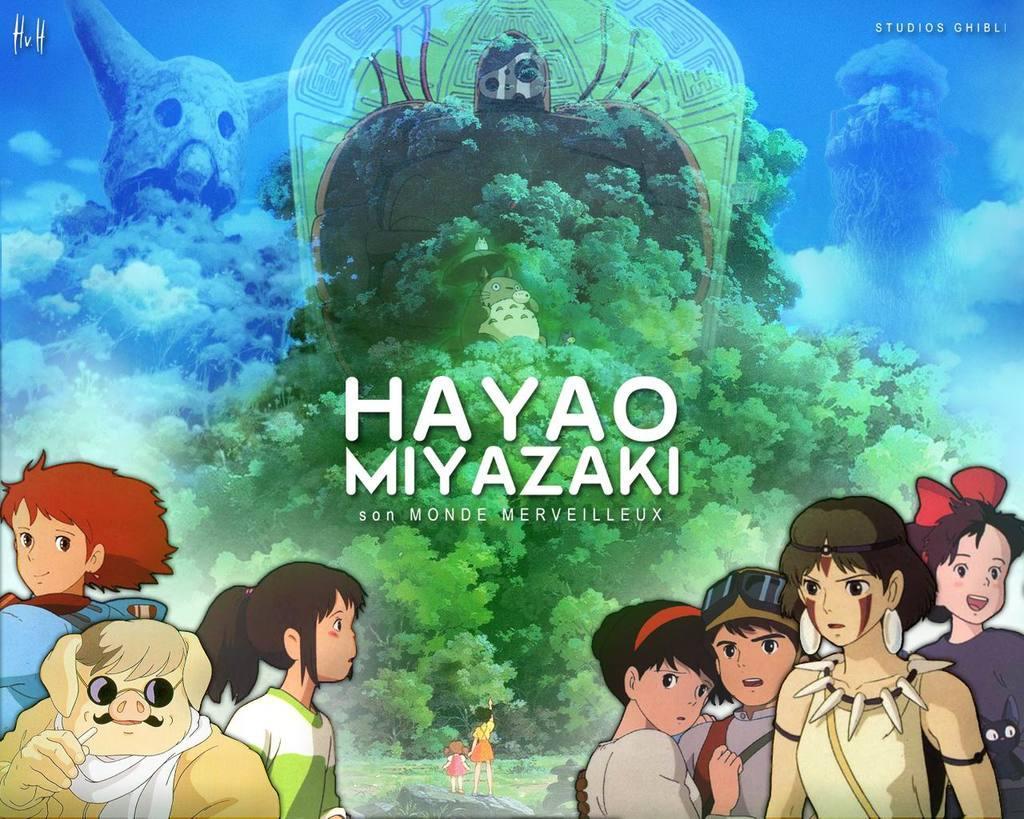Describe this image in one or two sentences. This image is a cartoon. In the center of the image we can see text. On the right and left side of the image we can see persons. In the background we can see persons, grass, stones, trees, sky and clouds. 